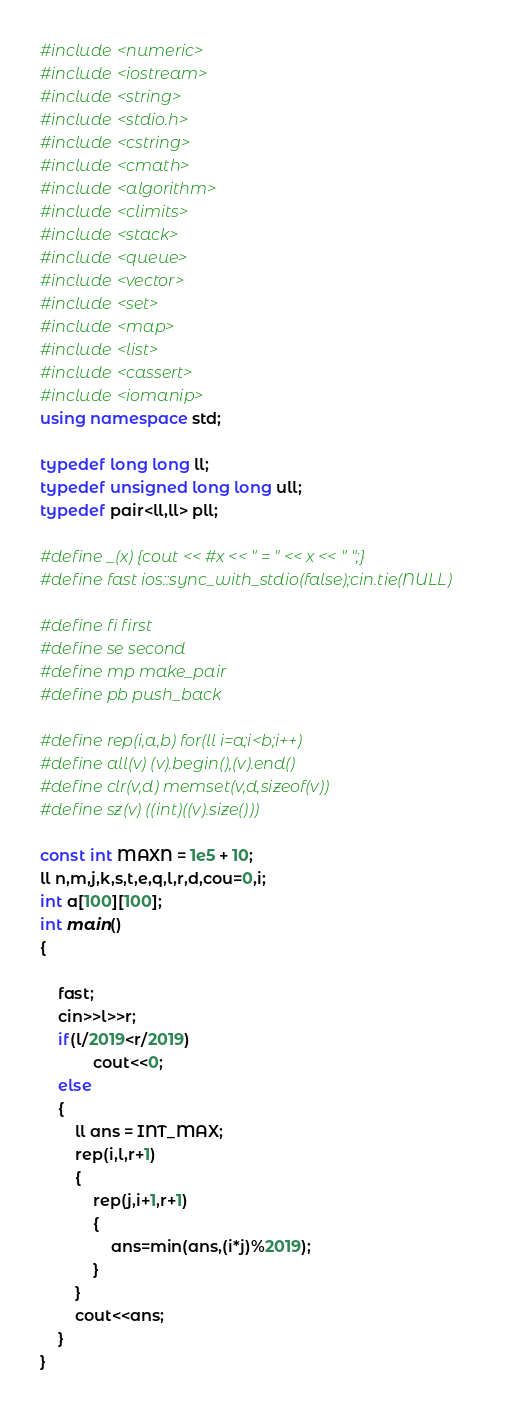<code> <loc_0><loc_0><loc_500><loc_500><_C++_>#include <numeric>
#include <iostream>
#include <string>
#include <stdio.h>
#include <cstring>
#include <cmath>
#include <algorithm>
#include <climits>
#include <stack>
#include <queue>
#include <vector>
#include <set>
#include <map>
#include <list>
#include <cassert>
#include <iomanip>
using namespace std;

typedef long long ll;
typedef unsigned long long ull;
typedef pair<ll,ll> pll;

#define _(x) {cout << #x << " = " << x << " ";}
#define fast ios::sync_with_stdio(false);cin.tie(NULL)

#define fi first 
#define se second 
#define mp make_pair
#define pb push_back

#define rep(i,a,b) for(ll i=a;i<b;i++)
#define all(v) (v).begin(),(v).end()
#define clr(v,d) memset(v,d,sizeof(v))
#define sz(v) ((int)((v).size()))

const int MAXN = 1e5 + 10;
ll n,m,j,k,s,t,e,q,l,r,d,cou=0,i;
int a[100][100];
int main()
{   
    
    fast;
    cin>>l>>r;
    if(l/2019<r/2019)
            cout<<0;
    else
    {
        ll ans = INT_MAX;
        rep(i,l,r+1)
        {
            rep(j,i+1,r+1)
            {
                ans=min(ans,(i*j)%2019);
            }
        }
        cout<<ans;
    }
}
</code> 